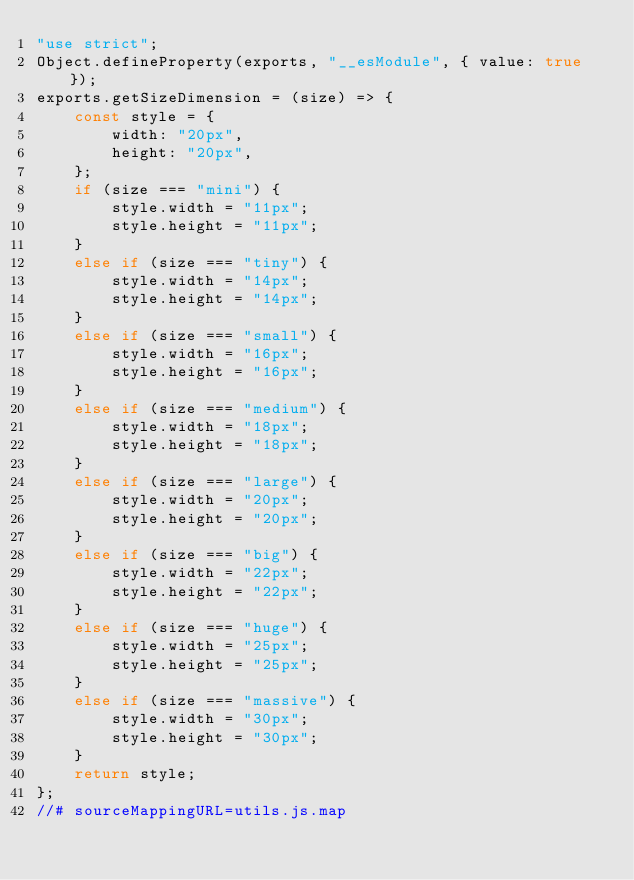<code> <loc_0><loc_0><loc_500><loc_500><_JavaScript_>"use strict";
Object.defineProperty(exports, "__esModule", { value: true });
exports.getSizeDimension = (size) => {
    const style = {
        width: "20px",
        height: "20px",
    };
    if (size === "mini") {
        style.width = "11px";
        style.height = "11px";
    }
    else if (size === "tiny") {
        style.width = "14px";
        style.height = "14px";
    }
    else if (size === "small") {
        style.width = "16px";
        style.height = "16px";
    }
    else if (size === "medium") {
        style.width = "18px";
        style.height = "18px";
    }
    else if (size === "large") {
        style.width = "20px";
        style.height = "20px";
    }
    else if (size === "big") {
        style.width = "22px";
        style.height = "22px";
    }
    else if (size === "huge") {
        style.width = "25px";
        style.height = "25px";
    }
    else if (size === "massive") {
        style.width = "30px";
        style.height = "30px";
    }
    return style;
};
//# sourceMappingURL=utils.js.map</code> 